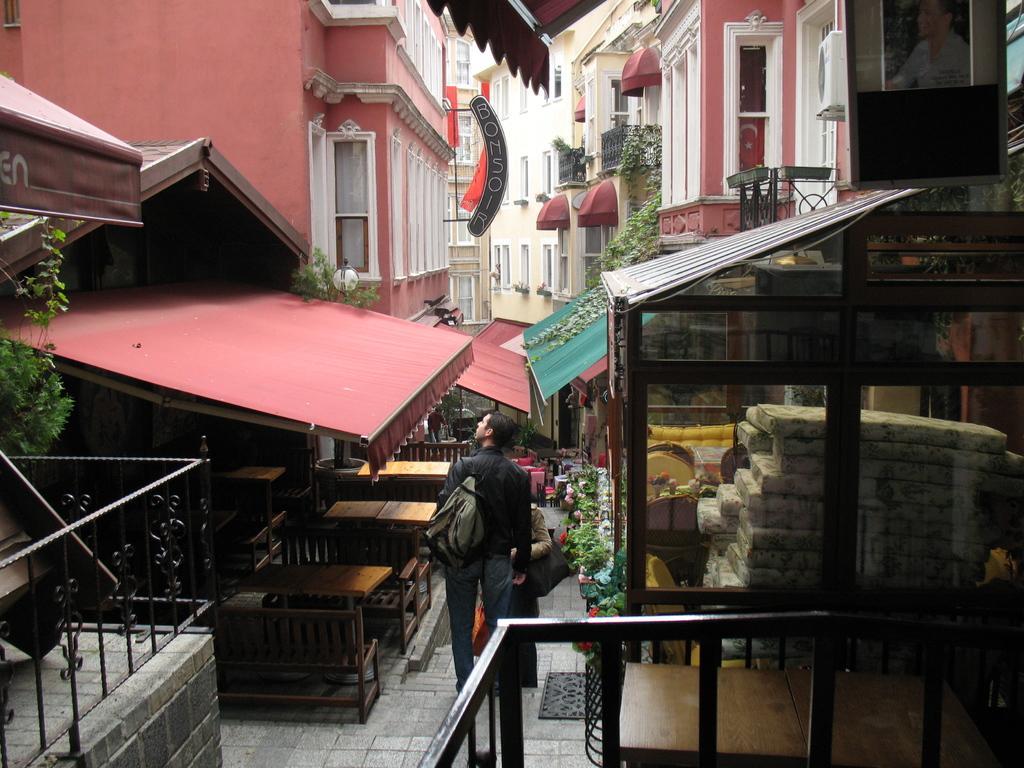Could you give a brief overview of what you see in this image? In the foreground of this image, there is a path on which there are two people wearing bags are working on it and on either side there are buildings in the background that chairs tables and it seems like a shelter on the right. 